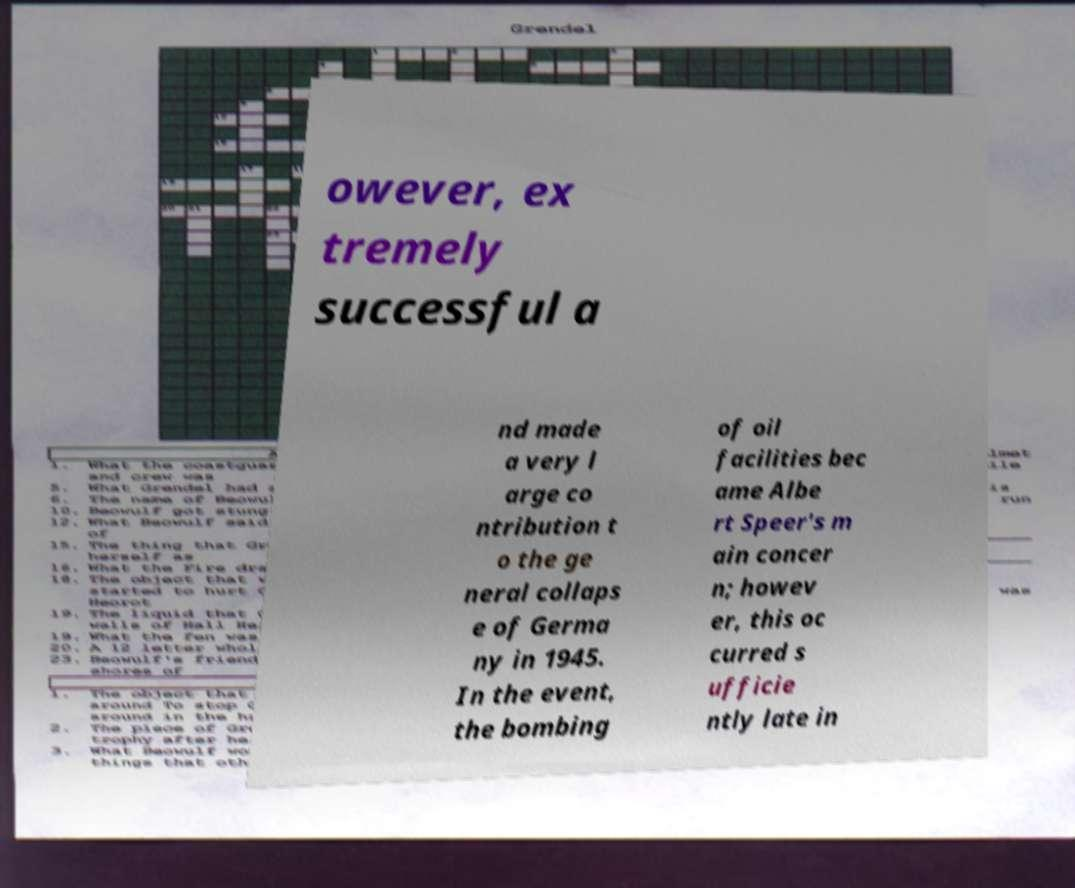Please read and relay the text visible in this image. What does it say? owever, ex tremely successful a nd made a very l arge co ntribution t o the ge neral collaps e of Germa ny in 1945. In the event, the bombing of oil facilities bec ame Albe rt Speer's m ain concer n; howev er, this oc curred s ufficie ntly late in 